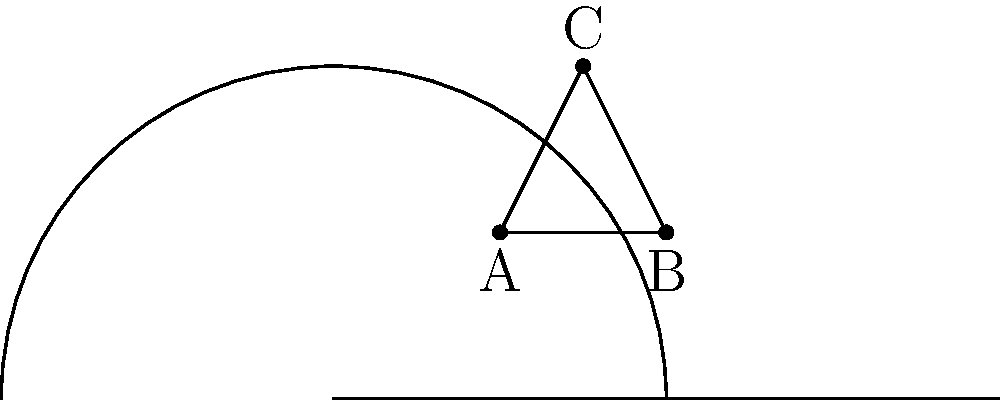In the upper half-plane model of hyperbolic geometry, consider the triangle ABC with vertices A(1,1), B(2,1), and C(1.5,2). Calculate the area of this triangle using the formula:

$$\text{Area} = \pi - (\alpha + \beta + \gamma)$$

where $\alpha$, $\beta$, and $\gamma$ are the angles of the triangle in radians. Round your answer to two decimal places. To solve this problem, we need to follow these steps:

1) In the upper half-plane model, the angles are the same as in Euclidean geometry. We can calculate them using the dot product formula:

   $\cos \theta = \frac{\vec{u} \cdot \vec{v}}{|\vec{u}||\vec{v}|}$

2) For angle A:
   $\vec{AB} = (1,0)$, $\vec{AC} = (0.5,1)$
   $\cos A = \frac{1 \cdot 0.5 + 0 \cdot 1}{\sqrt{1^2 + 0^2}\sqrt{0.5^2 + 1^2}} = \frac{0.5}{\sqrt{1.25}} = 0.4472$
   $A = \arccos(0.4472) = 1.1071$ radians

3) For angle B:
   $\vec{BA} = (-1,0)$, $\vec{BC} = (-0.5,1)$
   $\cos B = \frac{0.5}{\sqrt{1.25}} = 0.4472$
   $B = \arccos(0.4472) = 1.1071$ radians

4) For angle C:
   $\vec{CA} = (-0.5,-1)$, $\vec{CB} = (0.5,-1)$
   $\cos C = \frac{0.25 + 1}{\sqrt{1.25}\sqrt{1.25}} = 1$
   $C = \arccos(1) = 0$ radians

5) Now we can apply the formula:
   Area = $\pi - (1.1071 + 1.1071 + 0) = \pi - 2.2142 = 0.9274$

6) Rounding to two decimal places: 0.93

This result showcases the unique properties of hyperbolic geometry, where the sum of angles in a triangle is less than $\pi$, leading to a positive area value when using this formula.
Answer: 0.93 